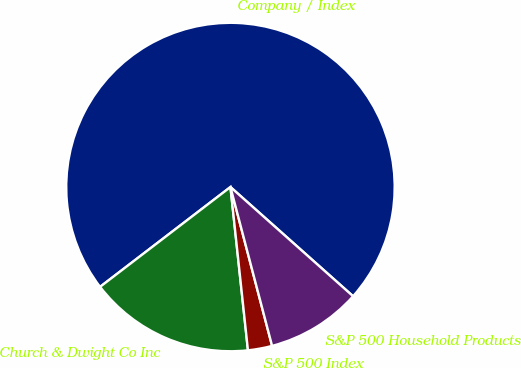Convert chart to OTSL. <chart><loc_0><loc_0><loc_500><loc_500><pie_chart><fcel>Company / Index<fcel>Church & Dwight Co Inc<fcel>S&P 500 Index<fcel>S&P 500 Household Products<nl><fcel>71.98%<fcel>16.3%<fcel>2.38%<fcel>9.34%<nl></chart> 